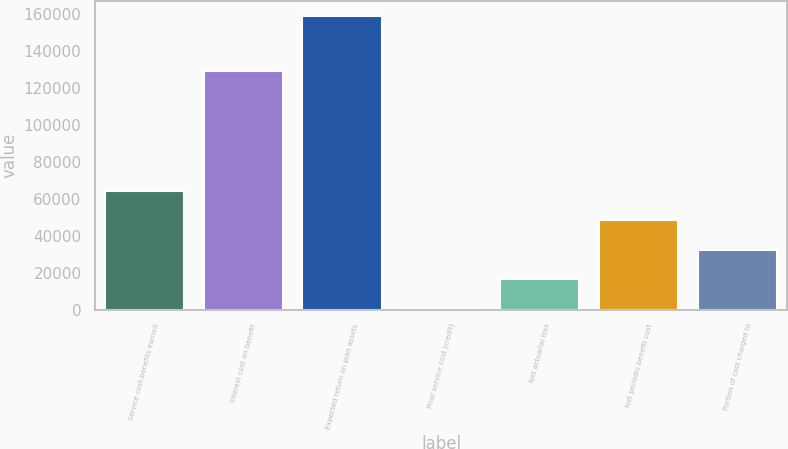Convert chart. <chart><loc_0><loc_0><loc_500><loc_500><bar_chart><fcel>Service cost-benefits earned<fcel>Interest cost on benefit<fcel>Expected return on plan assets<fcel>Prior service cost (credit)<fcel>Net actuarial loss<fcel>Net periodic benefit cost<fcel>Portion of cost charged to<nl><fcel>64120.6<fcel>129194<fcel>158998<fcel>869<fcel>16681.9<fcel>48307.7<fcel>32494.8<nl></chart> 